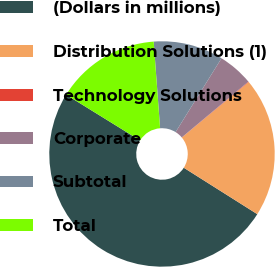Convert chart. <chart><loc_0><loc_0><loc_500><loc_500><pie_chart><fcel>(Dollars in millions)<fcel>Distribution Solutions (1)<fcel>Technology Solutions<fcel>Corporate<fcel>Subtotal<fcel>Total<nl><fcel>49.85%<fcel>19.99%<fcel>0.07%<fcel>5.05%<fcel>10.03%<fcel>15.01%<nl></chart> 